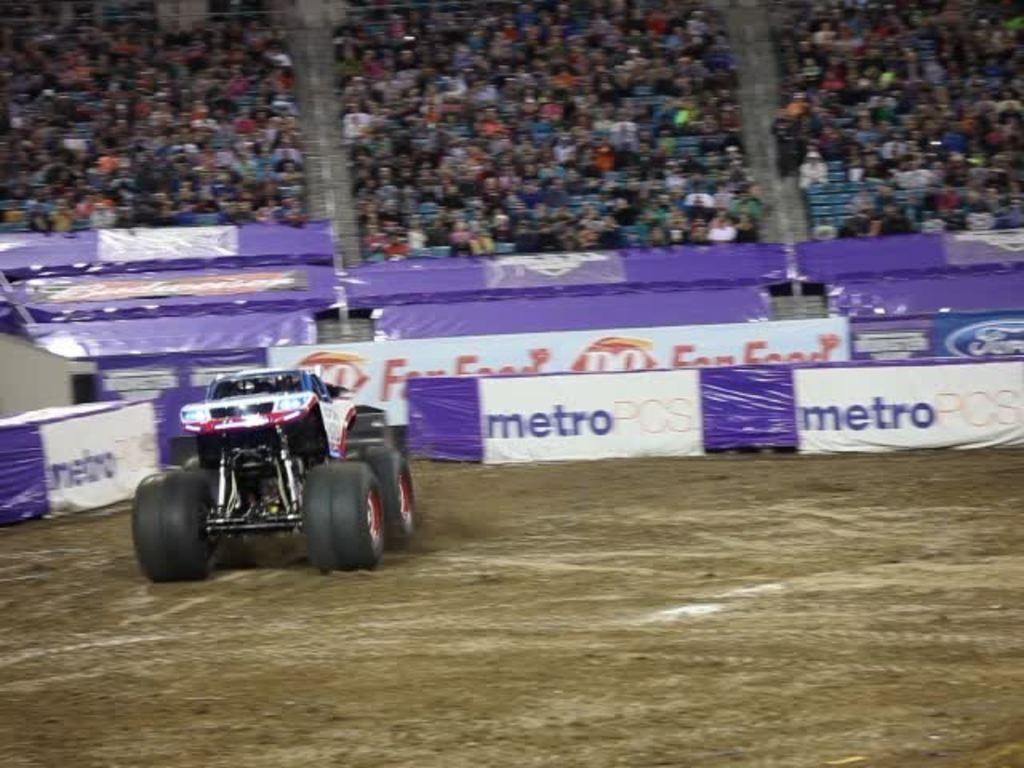What is the main object on the ground in the image? There is a vehicle on the ground in the image. How would you describe the background of the image? The background of the image has a blurred view. What else can be seen in the image besides the vehicle? There are banners in the image. Can you describe the people in the image? There is a group of people in the image. What type of arm is visible on the vehicle in the image? There is no specific arm visible on the vehicle in the image; it is a general term for a part of a vehicle. Can you tell me how many chess pieces are on the bed in the image? There is no bed or chess pieces present in the image. 